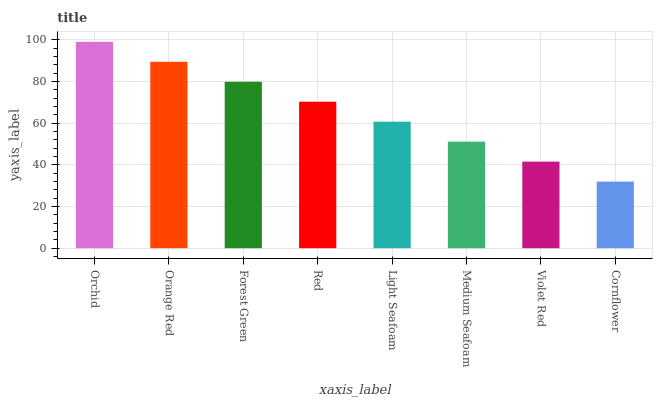Is Cornflower the minimum?
Answer yes or no. Yes. Is Orchid the maximum?
Answer yes or no. Yes. Is Orange Red the minimum?
Answer yes or no. No. Is Orange Red the maximum?
Answer yes or no. No. Is Orchid greater than Orange Red?
Answer yes or no. Yes. Is Orange Red less than Orchid?
Answer yes or no. Yes. Is Orange Red greater than Orchid?
Answer yes or no. No. Is Orchid less than Orange Red?
Answer yes or no. No. Is Red the high median?
Answer yes or no. Yes. Is Light Seafoam the low median?
Answer yes or no. Yes. Is Orange Red the high median?
Answer yes or no. No. Is Red the low median?
Answer yes or no. No. 